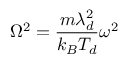Convert formula to latex. <formula><loc_0><loc_0><loc_500><loc_500>\Omega ^ { 2 } = \frac { m \lambda _ { d } ^ { 2 } } { k _ { B } T _ { d } } \omega ^ { 2 }</formula> 